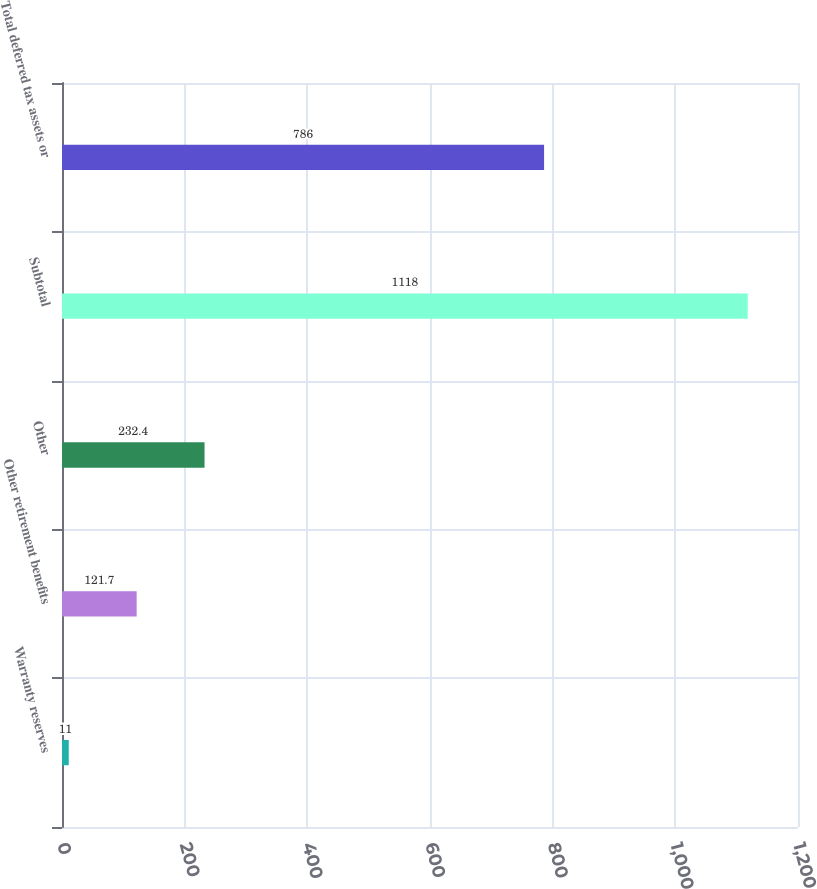<chart> <loc_0><loc_0><loc_500><loc_500><bar_chart><fcel>Warranty reserves<fcel>Other retirement benefits<fcel>Other<fcel>Subtotal<fcel>Total deferred tax assets or<nl><fcel>11<fcel>121.7<fcel>232.4<fcel>1118<fcel>786<nl></chart> 